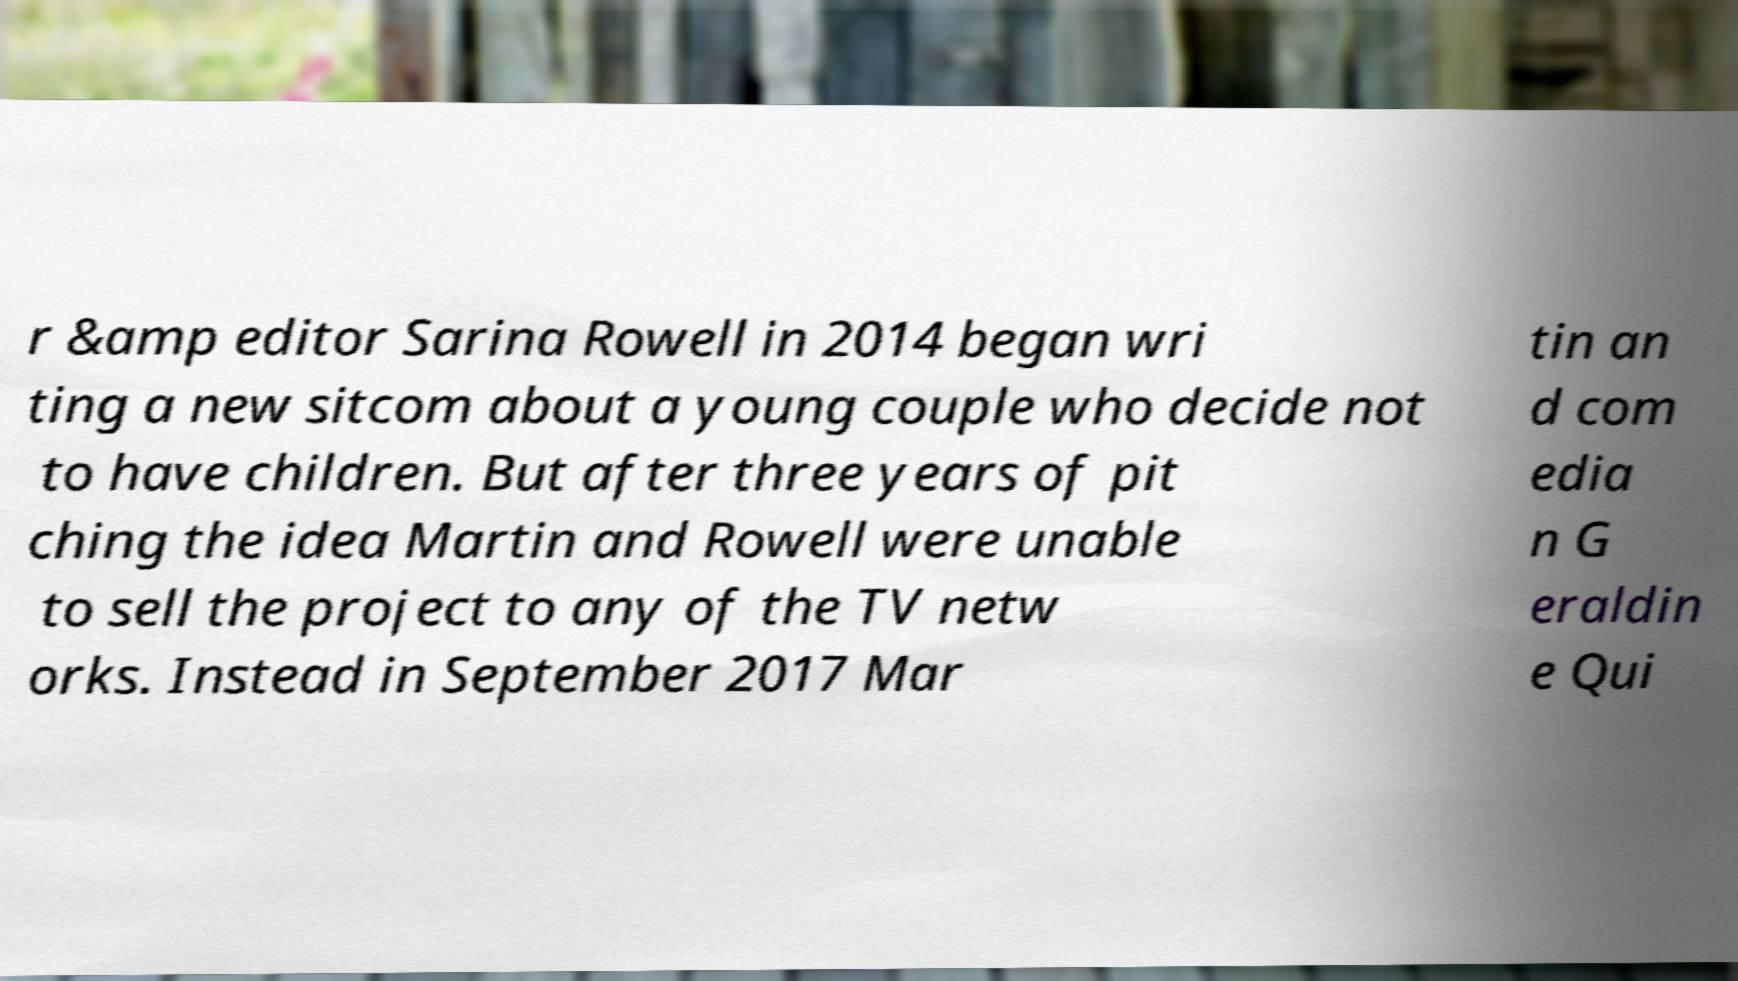Please read and relay the text visible in this image. What does it say? r &amp editor Sarina Rowell in 2014 began wri ting a new sitcom about a young couple who decide not to have children. But after three years of pit ching the idea Martin and Rowell were unable to sell the project to any of the TV netw orks. Instead in September 2017 Mar tin an d com edia n G eraldin e Qui 